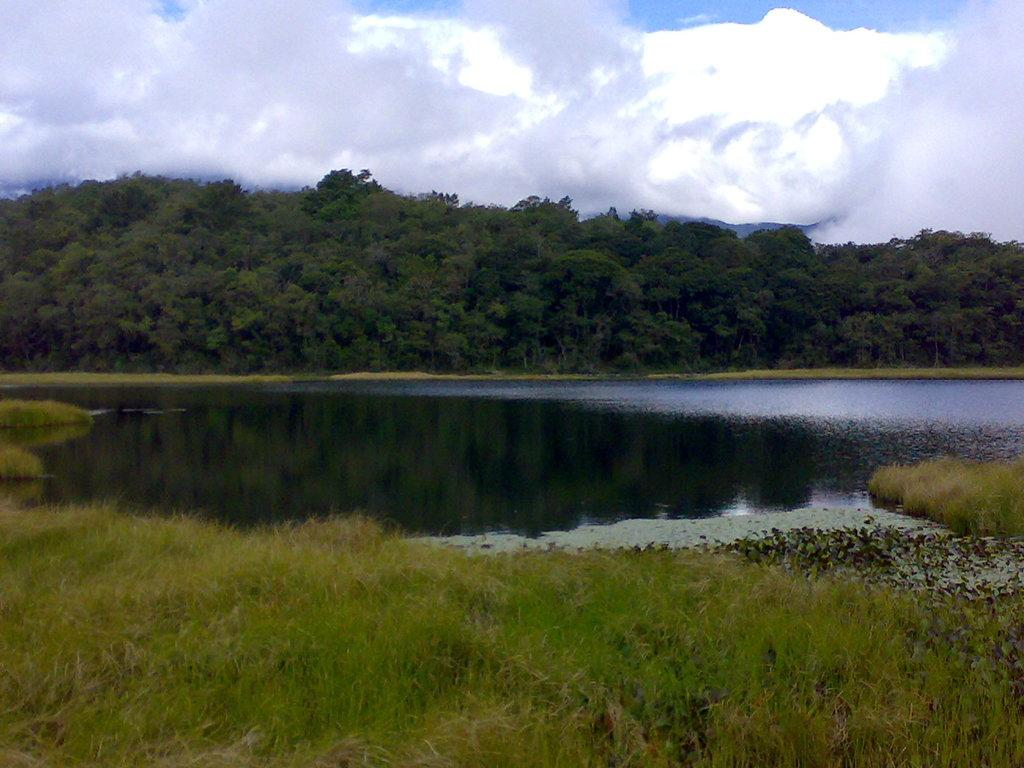What type of ground surface is visible in the image? There is grass on the ground in the image. What body of water can be seen in the image? There is a lake in the image. What type of vegetation is in the background of the image? There are trees in the background of the image. What is visible at the top of the image? The sky is visible at the top of the image. What can be seen in the sky in the image? Clouds are present in the sky. Where is the suit located in the image? There is no suit present in the image. What type of steel structure can be seen in the image? There is no steel structure present in the image. 